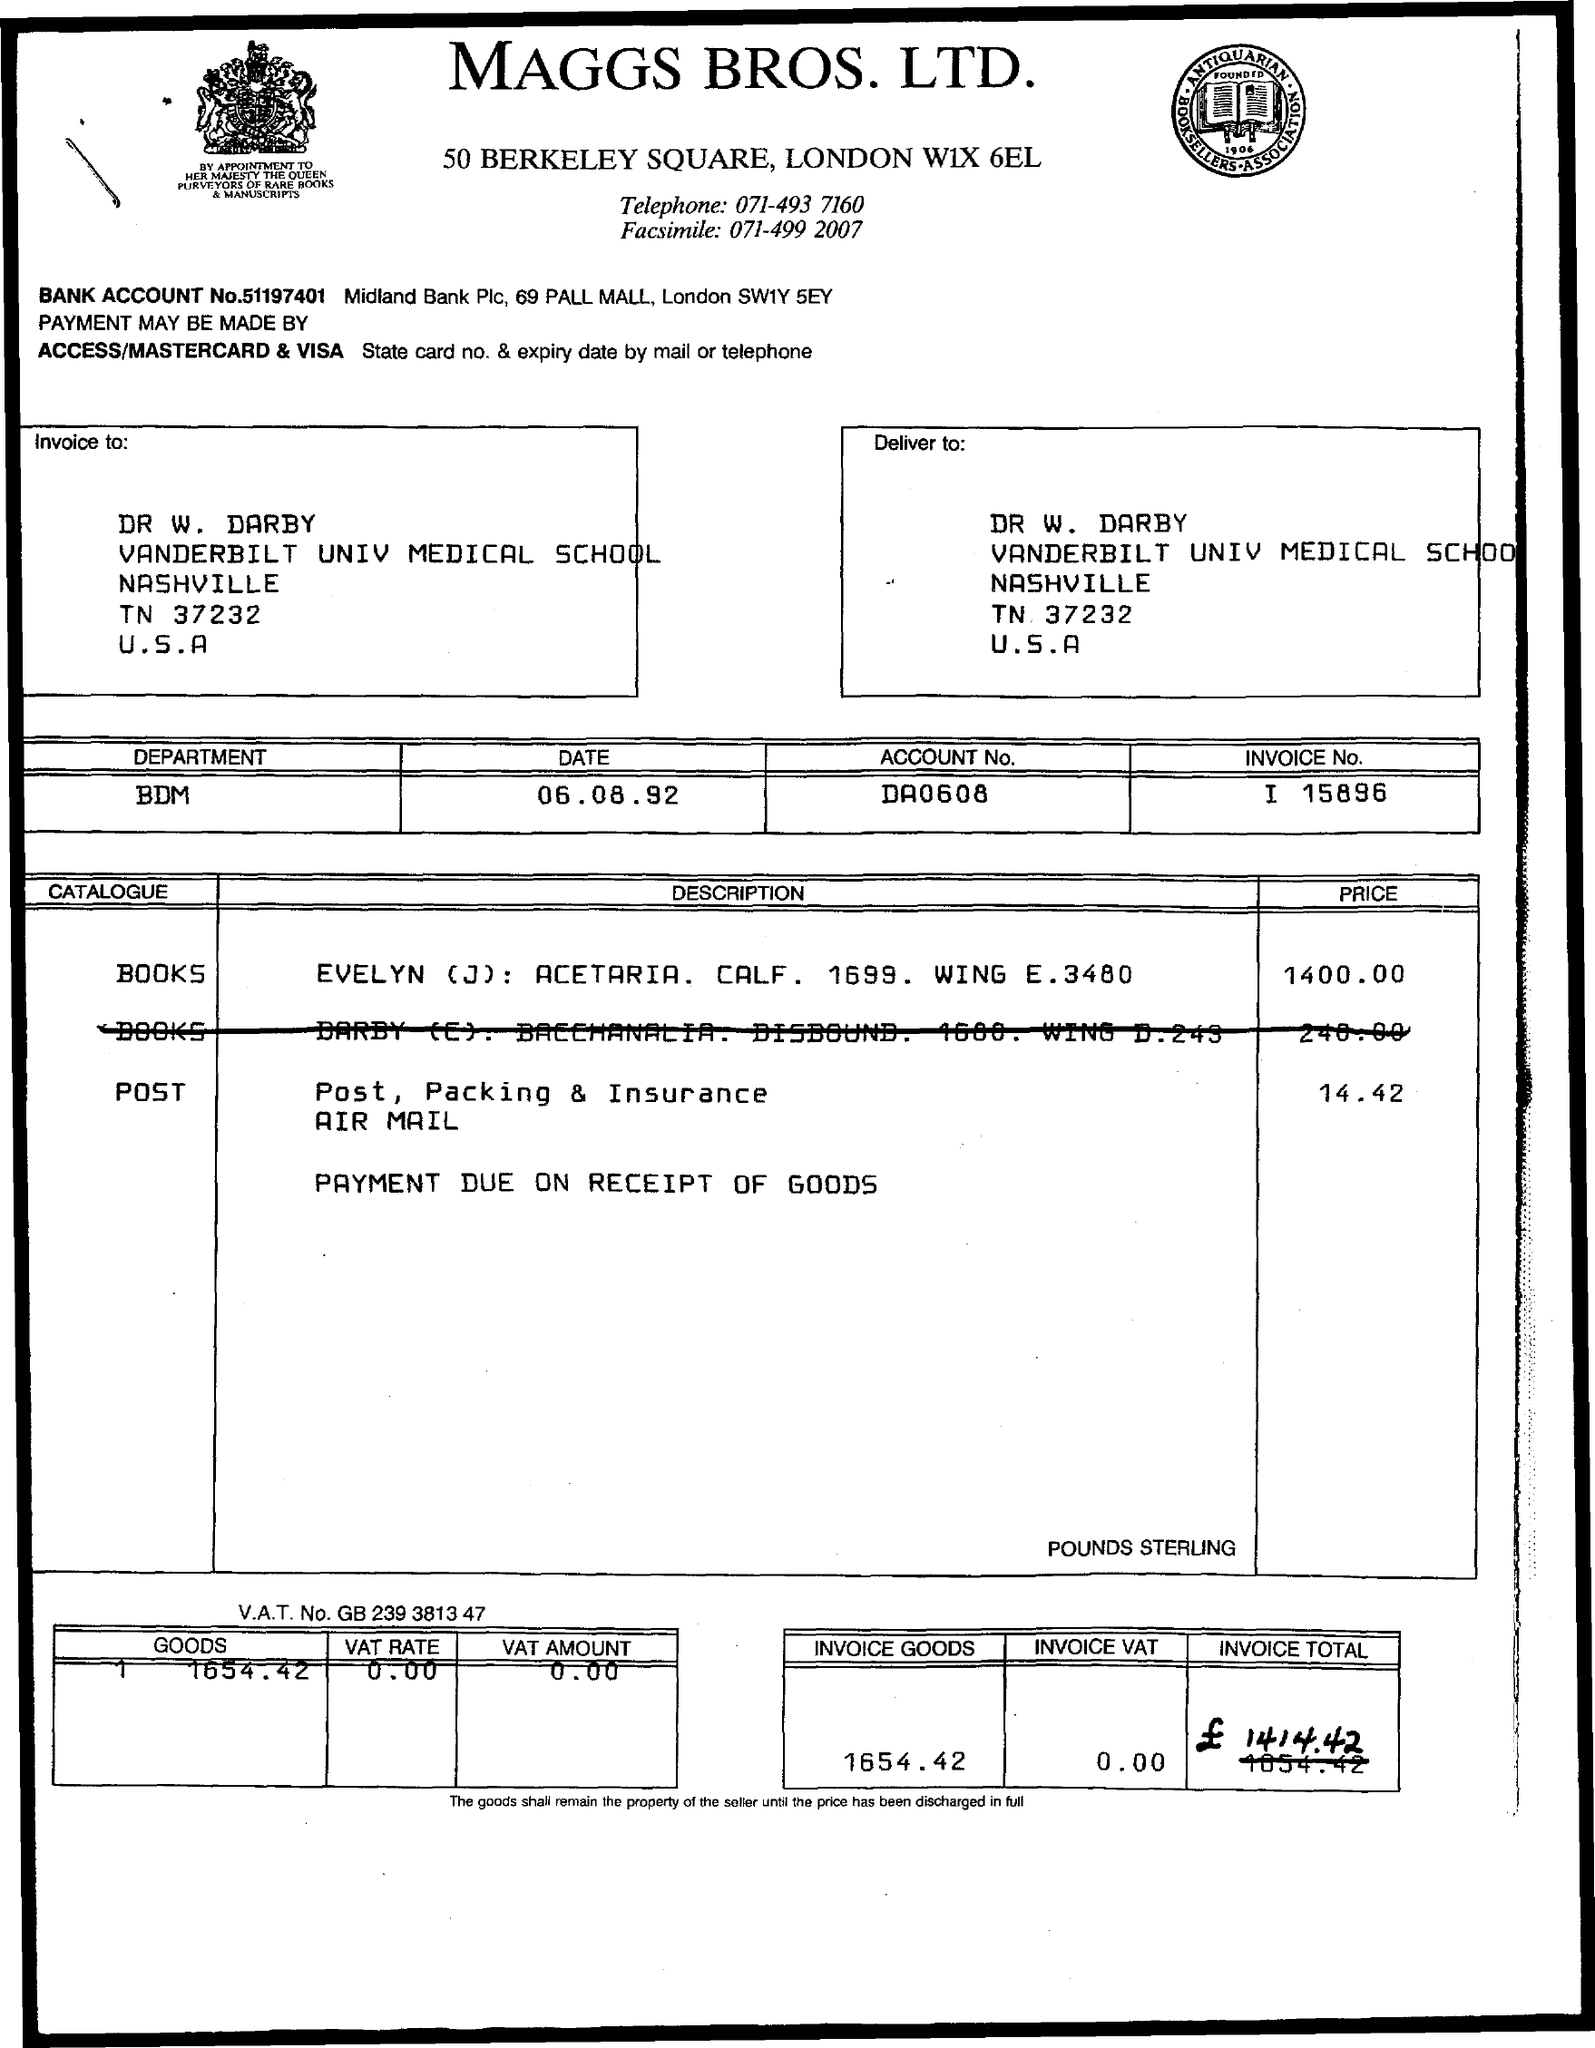Can you tell me the total due for the invoice? The total invoice amount due is £1654.42. 